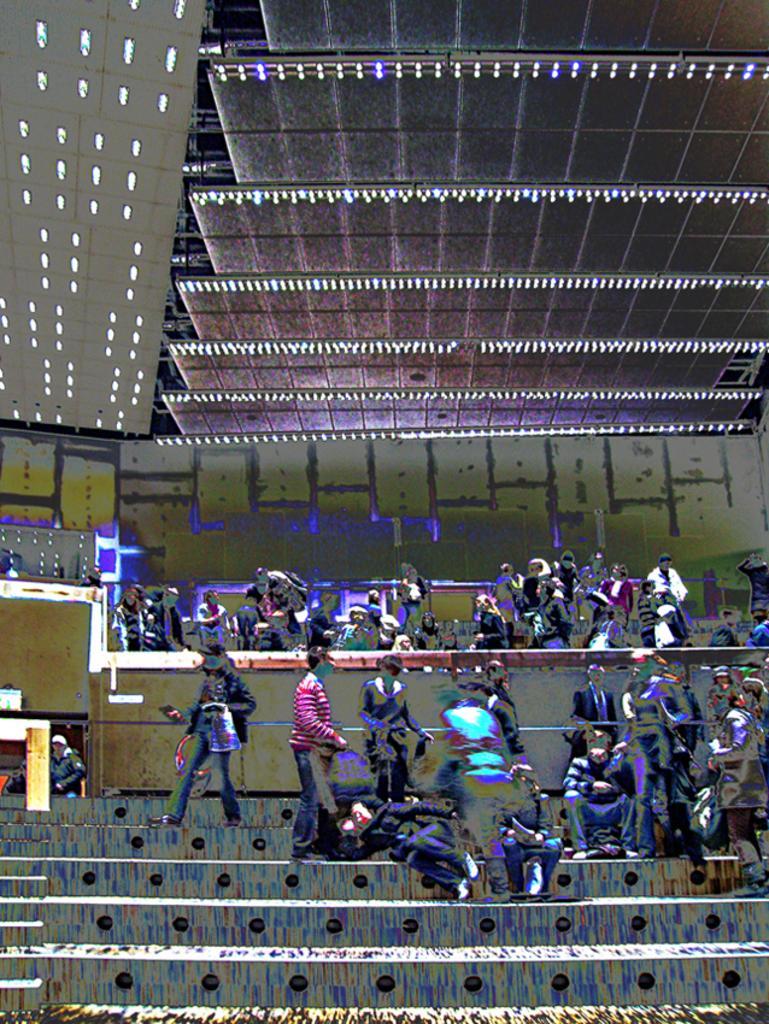Please provide a concise description of this image. This is an edited image. In this image we can see people. There are steps. Also there are lights. 